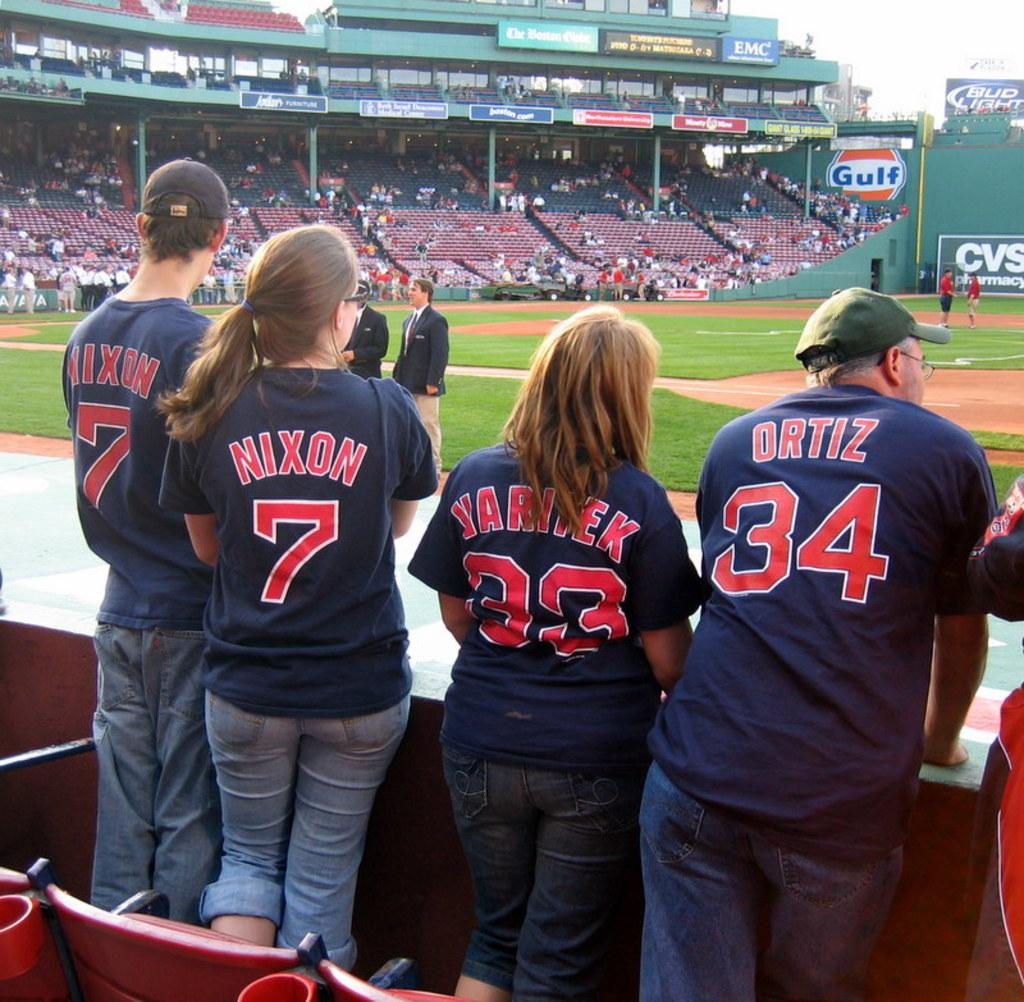<image>
Describe the image concisely. A man in a green hat is wearing a jersey that says Oritz and has the number 34 on it. 